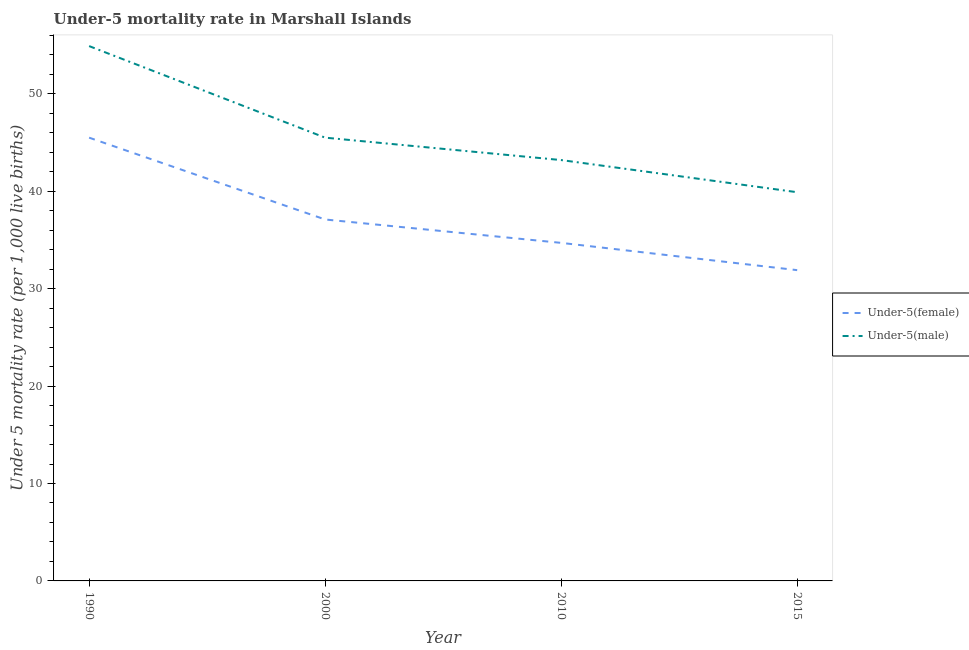How many different coloured lines are there?
Ensure brevity in your answer.  2. Is the number of lines equal to the number of legend labels?
Keep it short and to the point. Yes. What is the under-5 female mortality rate in 2000?
Provide a succinct answer. 37.1. Across all years, what is the maximum under-5 female mortality rate?
Your response must be concise. 45.5. Across all years, what is the minimum under-5 female mortality rate?
Keep it short and to the point. 31.9. In which year was the under-5 male mortality rate minimum?
Your response must be concise. 2015. What is the total under-5 female mortality rate in the graph?
Provide a short and direct response. 149.2. What is the difference between the under-5 male mortality rate in 1990 and that in 2000?
Provide a short and direct response. 9.4. What is the difference between the under-5 female mortality rate in 2000 and the under-5 male mortality rate in 2010?
Give a very brief answer. -6.1. What is the average under-5 male mortality rate per year?
Offer a terse response. 45.88. In how many years, is the under-5 male mortality rate greater than 26?
Give a very brief answer. 4. What is the ratio of the under-5 female mortality rate in 1990 to that in 2015?
Your response must be concise. 1.43. Is the under-5 female mortality rate in 2000 less than that in 2015?
Your answer should be compact. No. What is the difference between the highest and the second highest under-5 female mortality rate?
Your answer should be compact. 8.4. What is the difference between the highest and the lowest under-5 female mortality rate?
Your answer should be very brief. 13.6. Does the under-5 male mortality rate monotonically increase over the years?
Keep it short and to the point. No. Is the under-5 male mortality rate strictly greater than the under-5 female mortality rate over the years?
Your response must be concise. Yes. Is the under-5 male mortality rate strictly less than the under-5 female mortality rate over the years?
Provide a succinct answer. No. How many years are there in the graph?
Ensure brevity in your answer.  4. Does the graph contain any zero values?
Provide a short and direct response. No. Does the graph contain grids?
Your answer should be compact. No. What is the title of the graph?
Offer a very short reply. Under-5 mortality rate in Marshall Islands. Does "Ages 15-24" appear as one of the legend labels in the graph?
Offer a very short reply. No. What is the label or title of the X-axis?
Keep it short and to the point. Year. What is the label or title of the Y-axis?
Offer a terse response. Under 5 mortality rate (per 1,0 live births). What is the Under 5 mortality rate (per 1,000 live births) of Under-5(female) in 1990?
Provide a succinct answer. 45.5. What is the Under 5 mortality rate (per 1,000 live births) in Under-5(male) in 1990?
Your response must be concise. 54.9. What is the Under 5 mortality rate (per 1,000 live births) in Under-5(female) in 2000?
Your answer should be very brief. 37.1. What is the Under 5 mortality rate (per 1,000 live births) in Under-5(male) in 2000?
Your answer should be compact. 45.5. What is the Under 5 mortality rate (per 1,000 live births) in Under-5(female) in 2010?
Provide a succinct answer. 34.7. What is the Under 5 mortality rate (per 1,000 live births) in Under-5(male) in 2010?
Your response must be concise. 43.2. What is the Under 5 mortality rate (per 1,000 live births) in Under-5(female) in 2015?
Your answer should be compact. 31.9. What is the Under 5 mortality rate (per 1,000 live births) of Under-5(male) in 2015?
Provide a short and direct response. 39.9. Across all years, what is the maximum Under 5 mortality rate (per 1,000 live births) of Under-5(female)?
Make the answer very short. 45.5. Across all years, what is the maximum Under 5 mortality rate (per 1,000 live births) in Under-5(male)?
Provide a succinct answer. 54.9. Across all years, what is the minimum Under 5 mortality rate (per 1,000 live births) of Under-5(female)?
Offer a terse response. 31.9. Across all years, what is the minimum Under 5 mortality rate (per 1,000 live births) in Under-5(male)?
Offer a very short reply. 39.9. What is the total Under 5 mortality rate (per 1,000 live births) of Under-5(female) in the graph?
Give a very brief answer. 149.2. What is the total Under 5 mortality rate (per 1,000 live births) of Under-5(male) in the graph?
Your response must be concise. 183.5. What is the difference between the Under 5 mortality rate (per 1,000 live births) of Under-5(male) in 1990 and that in 2000?
Give a very brief answer. 9.4. What is the difference between the Under 5 mortality rate (per 1,000 live births) of Under-5(male) in 1990 and that in 2010?
Offer a terse response. 11.7. What is the difference between the Under 5 mortality rate (per 1,000 live births) of Under-5(female) in 2010 and that in 2015?
Offer a very short reply. 2.8. What is the difference between the Under 5 mortality rate (per 1,000 live births) of Under-5(male) in 2010 and that in 2015?
Provide a short and direct response. 3.3. What is the difference between the Under 5 mortality rate (per 1,000 live births) in Under-5(female) in 1990 and the Under 5 mortality rate (per 1,000 live births) in Under-5(male) in 2000?
Give a very brief answer. 0. What is the difference between the Under 5 mortality rate (per 1,000 live births) of Under-5(female) in 1990 and the Under 5 mortality rate (per 1,000 live births) of Under-5(male) in 2010?
Provide a short and direct response. 2.3. What is the difference between the Under 5 mortality rate (per 1,000 live births) in Under-5(female) in 2010 and the Under 5 mortality rate (per 1,000 live births) in Under-5(male) in 2015?
Make the answer very short. -5.2. What is the average Under 5 mortality rate (per 1,000 live births) of Under-5(female) per year?
Keep it short and to the point. 37.3. What is the average Under 5 mortality rate (per 1,000 live births) of Under-5(male) per year?
Provide a short and direct response. 45.88. In the year 2015, what is the difference between the Under 5 mortality rate (per 1,000 live births) of Under-5(female) and Under 5 mortality rate (per 1,000 live births) of Under-5(male)?
Ensure brevity in your answer.  -8. What is the ratio of the Under 5 mortality rate (per 1,000 live births) of Under-5(female) in 1990 to that in 2000?
Provide a succinct answer. 1.23. What is the ratio of the Under 5 mortality rate (per 1,000 live births) of Under-5(male) in 1990 to that in 2000?
Ensure brevity in your answer.  1.21. What is the ratio of the Under 5 mortality rate (per 1,000 live births) in Under-5(female) in 1990 to that in 2010?
Provide a short and direct response. 1.31. What is the ratio of the Under 5 mortality rate (per 1,000 live births) in Under-5(male) in 1990 to that in 2010?
Provide a succinct answer. 1.27. What is the ratio of the Under 5 mortality rate (per 1,000 live births) of Under-5(female) in 1990 to that in 2015?
Offer a very short reply. 1.43. What is the ratio of the Under 5 mortality rate (per 1,000 live births) in Under-5(male) in 1990 to that in 2015?
Your answer should be very brief. 1.38. What is the ratio of the Under 5 mortality rate (per 1,000 live births) of Under-5(female) in 2000 to that in 2010?
Your answer should be very brief. 1.07. What is the ratio of the Under 5 mortality rate (per 1,000 live births) of Under-5(male) in 2000 to that in 2010?
Make the answer very short. 1.05. What is the ratio of the Under 5 mortality rate (per 1,000 live births) in Under-5(female) in 2000 to that in 2015?
Provide a short and direct response. 1.16. What is the ratio of the Under 5 mortality rate (per 1,000 live births) in Under-5(male) in 2000 to that in 2015?
Keep it short and to the point. 1.14. What is the ratio of the Under 5 mortality rate (per 1,000 live births) of Under-5(female) in 2010 to that in 2015?
Offer a terse response. 1.09. What is the ratio of the Under 5 mortality rate (per 1,000 live births) of Under-5(male) in 2010 to that in 2015?
Provide a succinct answer. 1.08. What is the difference between the highest and the second highest Under 5 mortality rate (per 1,000 live births) of Under-5(female)?
Give a very brief answer. 8.4. What is the difference between the highest and the lowest Under 5 mortality rate (per 1,000 live births) of Under-5(female)?
Give a very brief answer. 13.6. What is the difference between the highest and the lowest Under 5 mortality rate (per 1,000 live births) of Under-5(male)?
Your response must be concise. 15. 